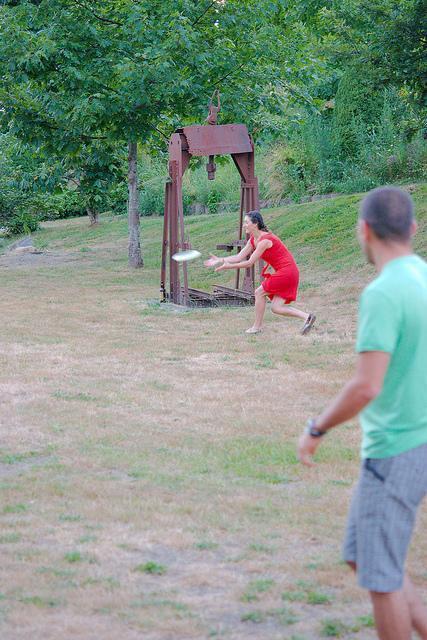How many people are in the shot?
Give a very brief answer. 2. How many people are in the picture?
Give a very brief answer. 2. How many people can you see?
Give a very brief answer. 2. 